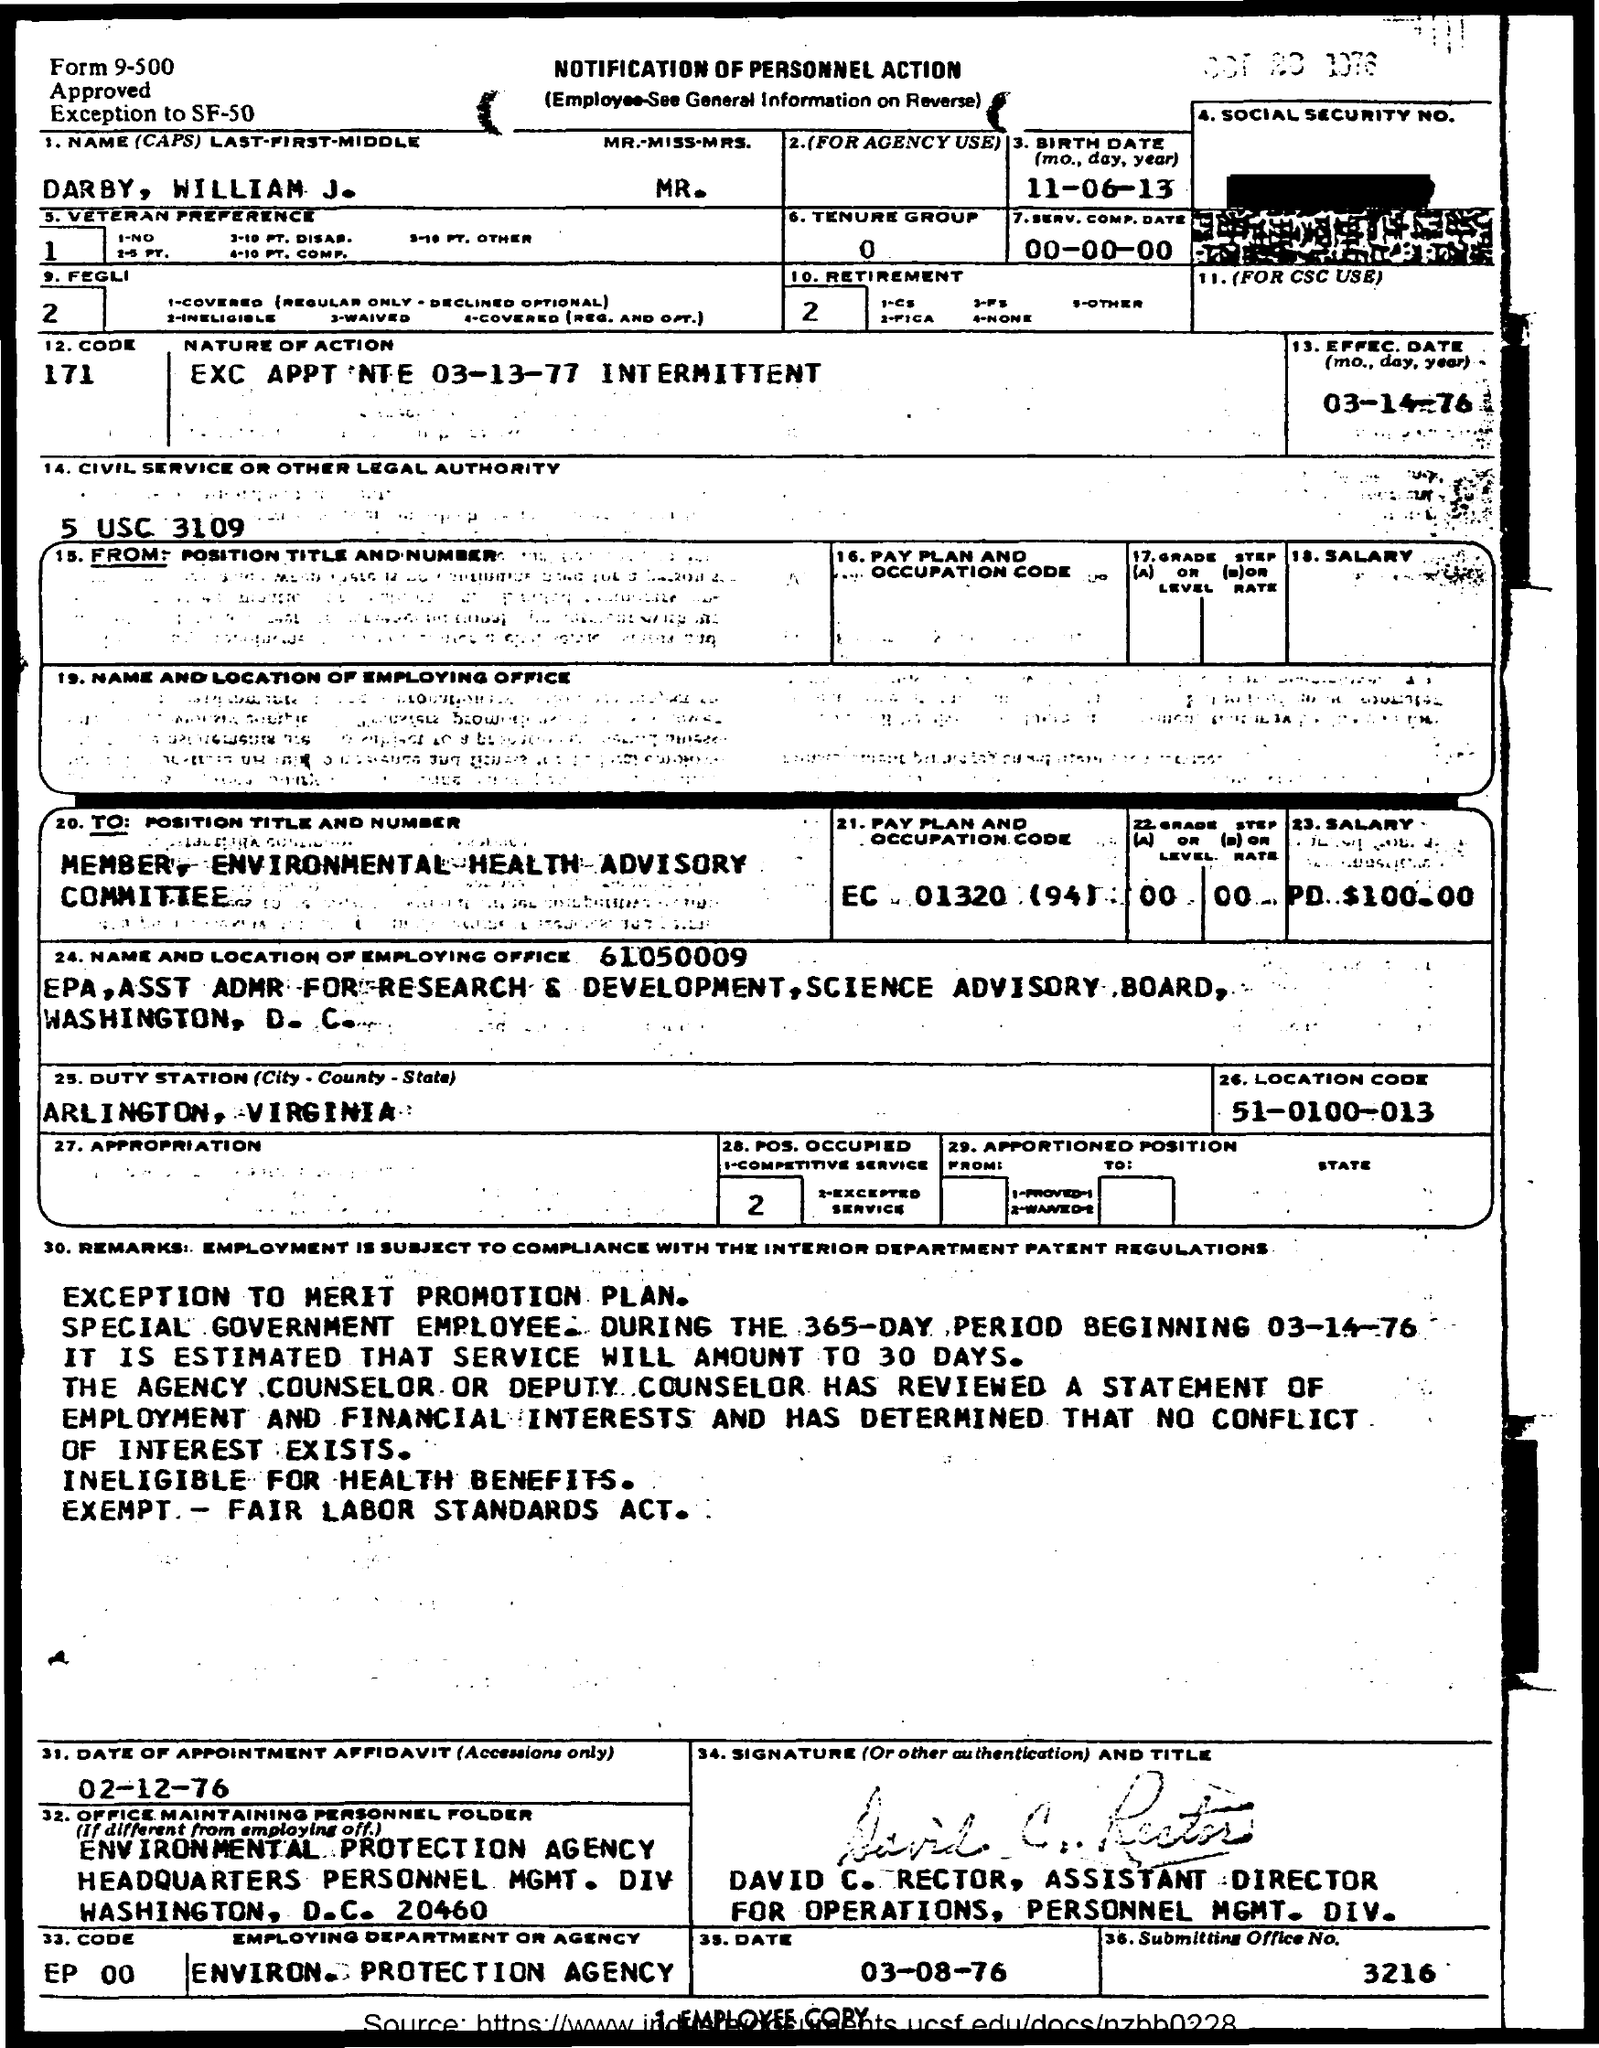Specify some key components in this picture. The question asks for the birth date of someone who was born on June 11, 2013. The location code is 51-0100-013. 